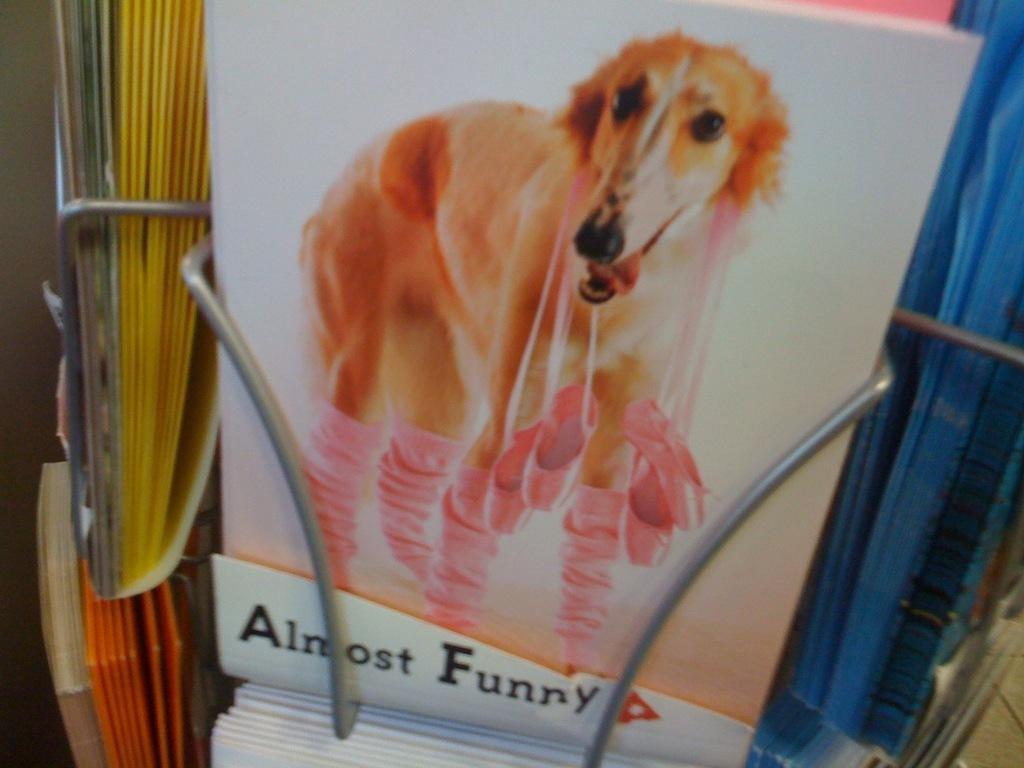Please provide a concise description of this image. In this image there is a bookshelf, in that there is a book on that book there is a dog picture, in the bottom there is some text. 